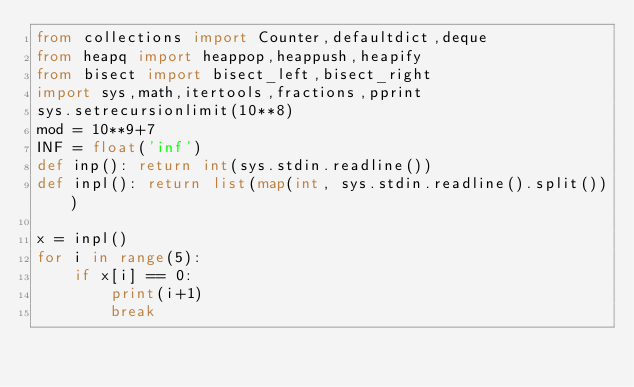Convert code to text. <code><loc_0><loc_0><loc_500><loc_500><_Python_>from collections import Counter,defaultdict,deque
from heapq import heappop,heappush,heapify
from bisect import bisect_left,bisect_right 
import sys,math,itertools,fractions,pprint
sys.setrecursionlimit(10**8)
mod = 10**9+7
INF = float('inf')
def inp(): return int(sys.stdin.readline())
def inpl(): return list(map(int, sys.stdin.readline().split()))

x = inpl()
for i in range(5):
    if x[i] == 0:
        print(i+1)
        break</code> 